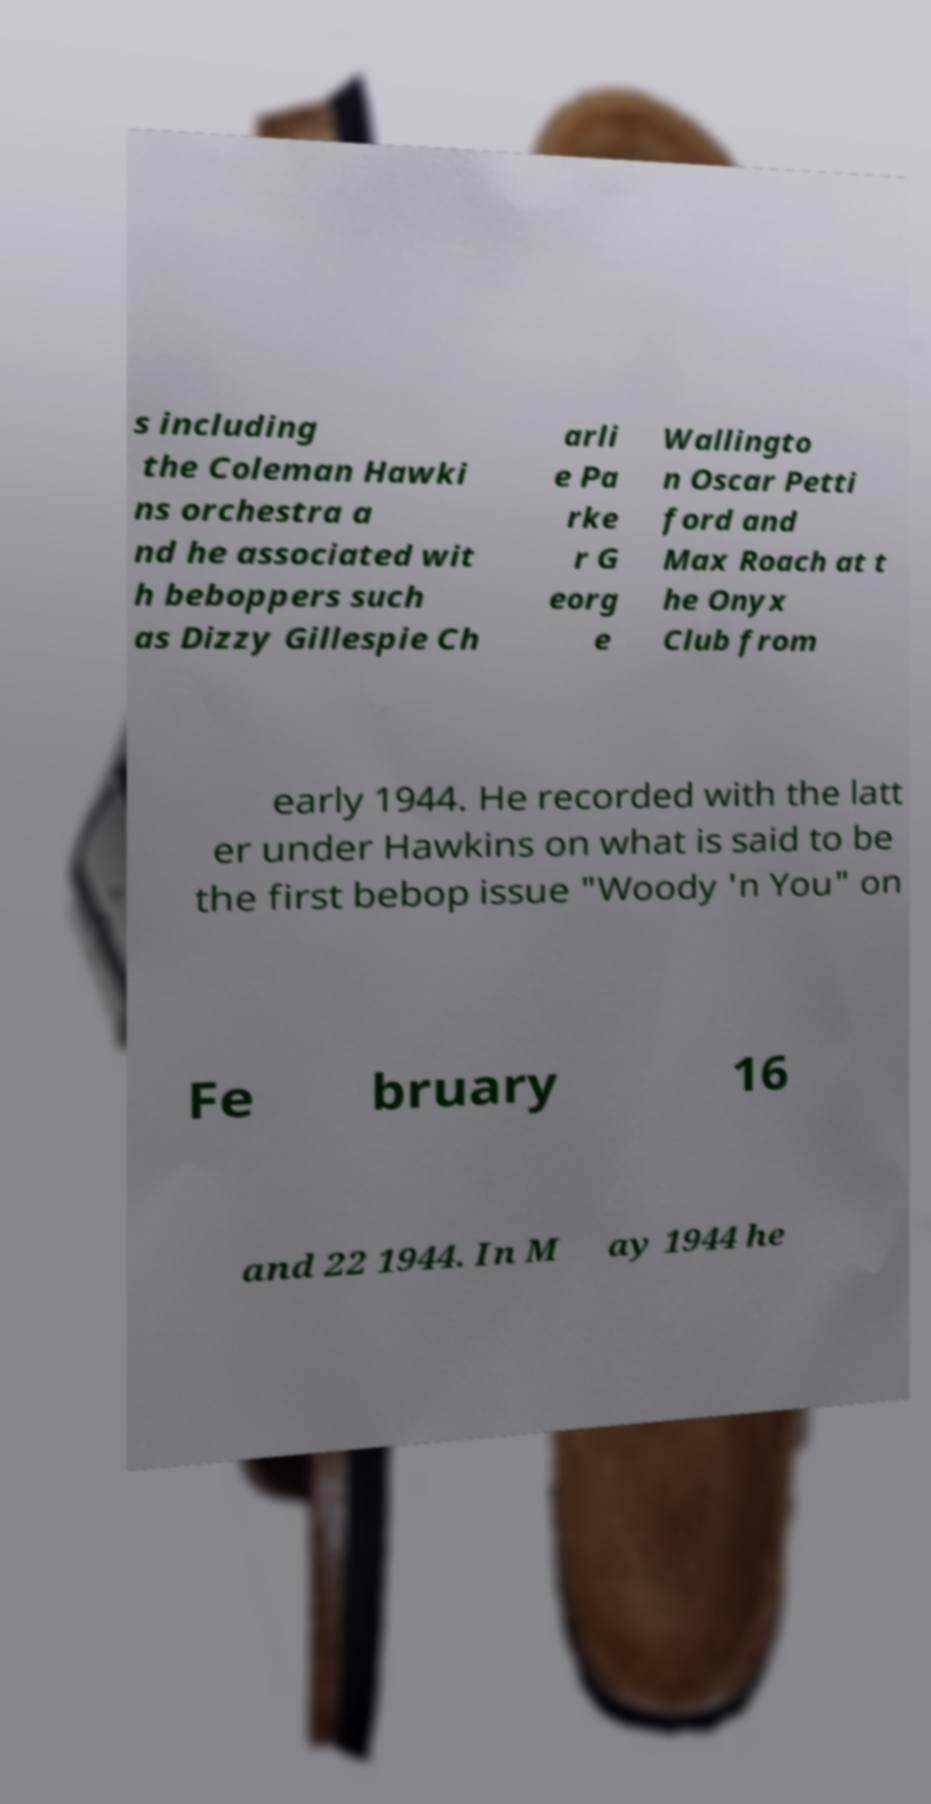Please identify and transcribe the text found in this image. s including the Coleman Hawki ns orchestra a nd he associated wit h beboppers such as Dizzy Gillespie Ch arli e Pa rke r G eorg e Wallingto n Oscar Petti ford and Max Roach at t he Onyx Club from early 1944. He recorded with the latt er under Hawkins on what is said to be the first bebop issue "Woody 'n You" on Fe bruary 16 and 22 1944. In M ay 1944 he 